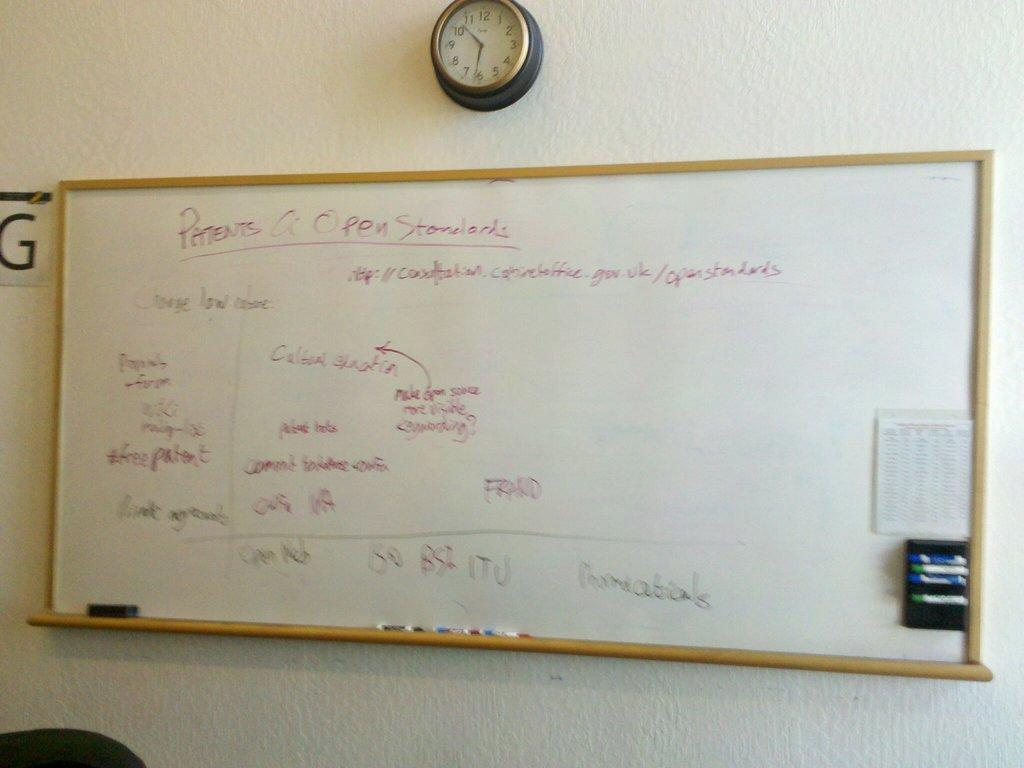<image>
Write a terse but informative summary of the picture. "Patents A Open Standards" is written on a white board. 